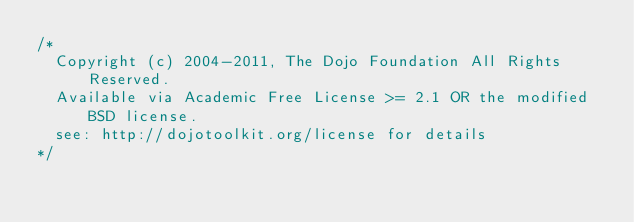Convert code to text. <code><loc_0><loc_0><loc_500><loc_500><_JavaScript_>/*
	Copyright (c) 2004-2011, The Dojo Foundation All Rights Reserved.
	Available via Academic Free License >= 2.1 OR the modified BSD license.
	see: http://dojotoolkit.org/license for details
*/

</code> 